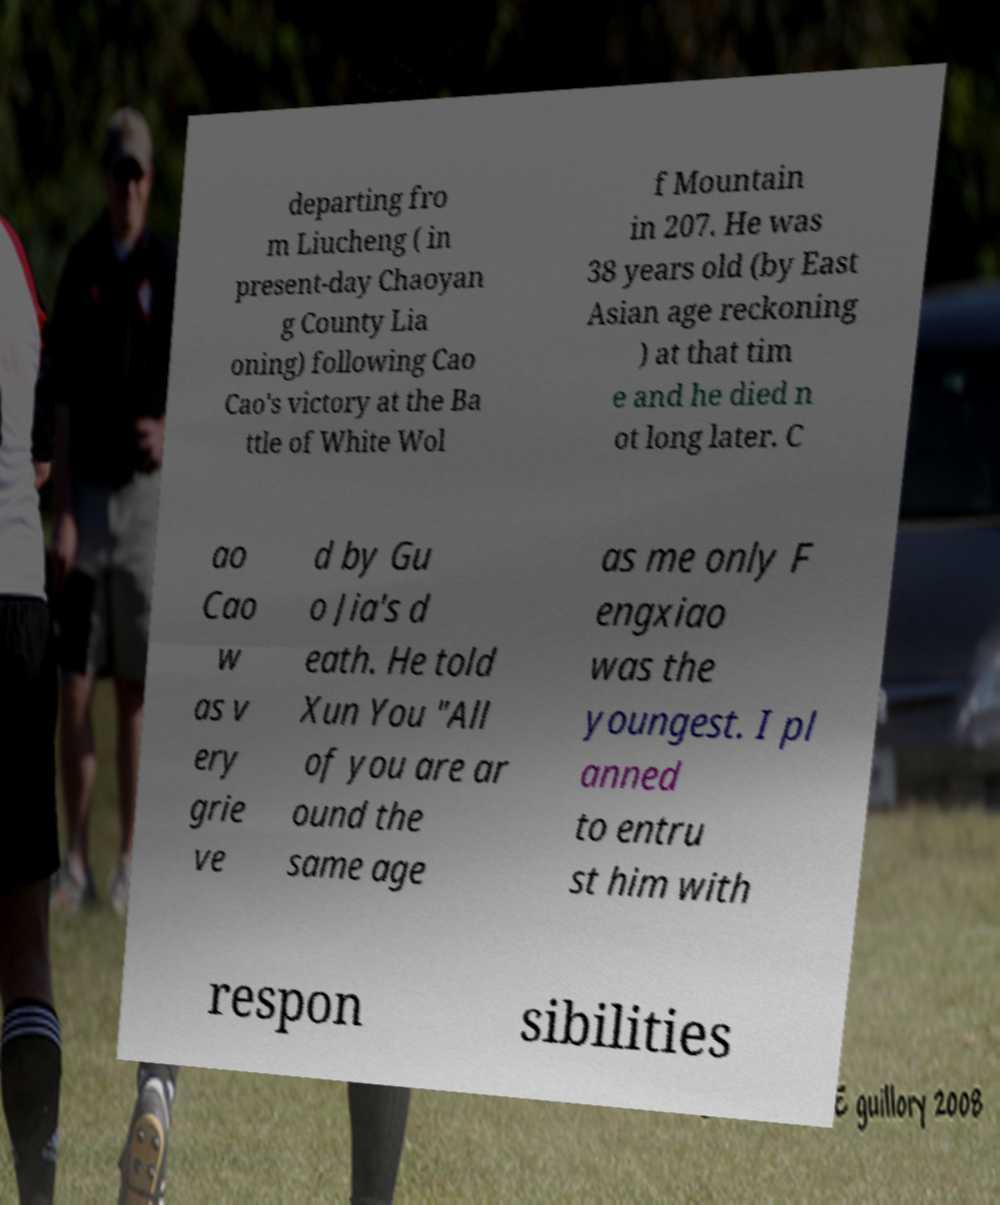Please identify and transcribe the text found in this image. departing fro m Liucheng ( in present-day Chaoyan g County Lia oning) following Cao Cao's victory at the Ba ttle of White Wol f Mountain in 207. He was 38 years old (by East Asian age reckoning ) at that tim e and he died n ot long later. C ao Cao w as v ery grie ve d by Gu o Jia's d eath. He told Xun You "All of you are ar ound the same age as me only F engxiao was the youngest. I pl anned to entru st him with respon sibilities 